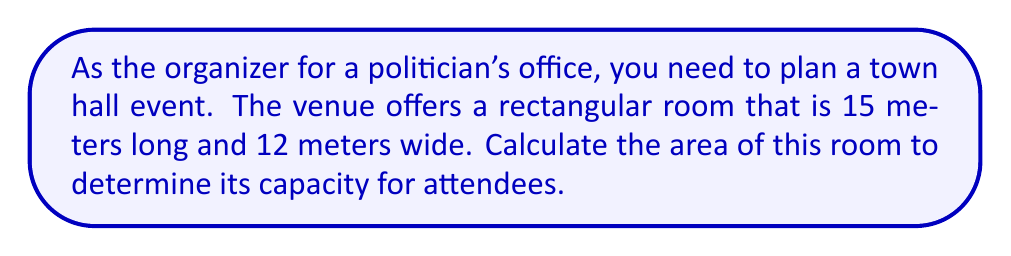What is the answer to this math problem? To calculate the area of a rectangular room, we use the formula:

$$A = l \times w$$

Where:
$A$ = Area
$l$ = Length
$w$ = Width

Given:
$l = 15$ meters
$w = 12$ meters

Step 1: Substitute the values into the formula
$$A = 15 \times 12$$

Step 2: Multiply
$$A = 180$$

Therefore, the area of the rectangular room is 180 square meters.

[asy]
unitsize(1cm);
draw((0,0)--(15,0)--(15,12)--(0,12)--cycle);
label("15 m", (7.5,0), S);
label("12 m", (15,6), E);
label("Area = 180 m²", (7.5,6), N);
[/asy]
Answer: $180 \text{ m}^2$ 